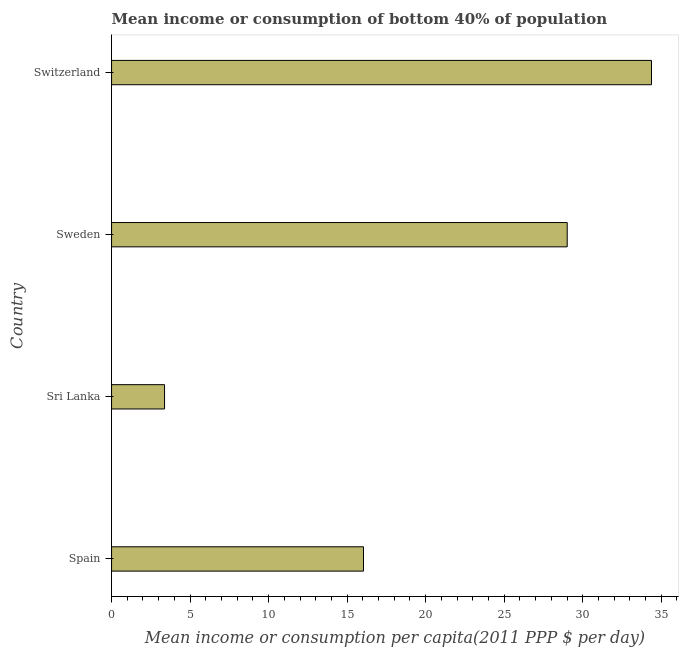What is the title of the graph?
Your response must be concise. Mean income or consumption of bottom 40% of population. What is the label or title of the X-axis?
Your answer should be compact. Mean income or consumption per capita(2011 PPP $ per day). What is the label or title of the Y-axis?
Offer a terse response. Country. What is the mean income or consumption in Sri Lanka?
Your response must be concise. 3.37. Across all countries, what is the maximum mean income or consumption?
Keep it short and to the point. 34.38. Across all countries, what is the minimum mean income or consumption?
Provide a succinct answer. 3.37. In which country was the mean income or consumption maximum?
Give a very brief answer. Switzerland. In which country was the mean income or consumption minimum?
Your answer should be compact. Sri Lanka. What is the sum of the mean income or consumption?
Keep it short and to the point. 82.81. What is the difference between the mean income or consumption in Spain and Sweden?
Give a very brief answer. -12.97. What is the average mean income or consumption per country?
Offer a terse response. 20.7. What is the median mean income or consumption?
Your answer should be compact. 22.53. In how many countries, is the mean income or consumption greater than 10 $?
Offer a very short reply. 3. What is the ratio of the mean income or consumption in Sri Lanka to that in Switzerland?
Make the answer very short. 0.1. Is the mean income or consumption in Spain less than that in Sri Lanka?
Offer a very short reply. No. What is the difference between the highest and the second highest mean income or consumption?
Offer a terse response. 5.37. Is the sum of the mean income or consumption in Spain and Switzerland greater than the maximum mean income or consumption across all countries?
Offer a terse response. Yes. How many countries are there in the graph?
Ensure brevity in your answer.  4. What is the difference between two consecutive major ticks on the X-axis?
Provide a short and direct response. 5. What is the Mean income or consumption per capita(2011 PPP $ per day) of Spain?
Offer a terse response. 16.04. What is the Mean income or consumption per capita(2011 PPP $ per day) in Sri Lanka?
Offer a terse response. 3.37. What is the Mean income or consumption per capita(2011 PPP $ per day) in Sweden?
Provide a short and direct response. 29.01. What is the Mean income or consumption per capita(2011 PPP $ per day) of Switzerland?
Offer a very short reply. 34.38. What is the difference between the Mean income or consumption per capita(2011 PPP $ per day) in Spain and Sri Lanka?
Give a very brief answer. 12.67. What is the difference between the Mean income or consumption per capita(2011 PPP $ per day) in Spain and Sweden?
Make the answer very short. -12.97. What is the difference between the Mean income or consumption per capita(2011 PPP $ per day) in Spain and Switzerland?
Offer a terse response. -18.34. What is the difference between the Mean income or consumption per capita(2011 PPP $ per day) in Sri Lanka and Sweden?
Ensure brevity in your answer.  -25.64. What is the difference between the Mean income or consumption per capita(2011 PPP $ per day) in Sri Lanka and Switzerland?
Your answer should be very brief. -31. What is the difference between the Mean income or consumption per capita(2011 PPP $ per day) in Sweden and Switzerland?
Give a very brief answer. -5.37. What is the ratio of the Mean income or consumption per capita(2011 PPP $ per day) in Spain to that in Sri Lanka?
Give a very brief answer. 4.75. What is the ratio of the Mean income or consumption per capita(2011 PPP $ per day) in Spain to that in Sweden?
Your answer should be compact. 0.55. What is the ratio of the Mean income or consumption per capita(2011 PPP $ per day) in Spain to that in Switzerland?
Make the answer very short. 0.47. What is the ratio of the Mean income or consumption per capita(2011 PPP $ per day) in Sri Lanka to that in Sweden?
Offer a very short reply. 0.12. What is the ratio of the Mean income or consumption per capita(2011 PPP $ per day) in Sri Lanka to that in Switzerland?
Your answer should be very brief. 0.1. What is the ratio of the Mean income or consumption per capita(2011 PPP $ per day) in Sweden to that in Switzerland?
Your response must be concise. 0.84. 